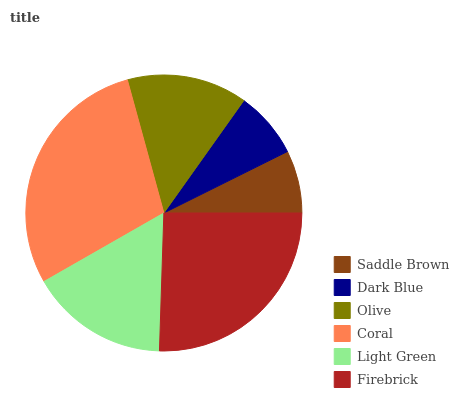Is Saddle Brown the minimum?
Answer yes or no. Yes. Is Coral the maximum?
Answer yes or no. Yes. Is Dark Blue the minimum?
Answer yes or no. No. Is Dark Blue the maximum?
Answer yes or no. No. Is Dark Blue greater than Saddle Brown?
Answer yes or no. Yes. Is Saddle Brown less than Dark Blue?
Answer yes or no. Yes. Is Saddle Brown greater than Dark Blue?
Answer yes or no. No. Is Dark Blue less than Saddle Brown?
Answer yes or no. No. Is Light Green the high median?
Answer yes or no. Yes. Is Olive the low median?
Answer yes or no. Yes. Is Olive the high median?
Answer yes or no. No. Is Firebrick the low median?
Answer yes or no. No. 